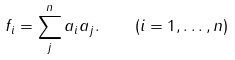Convert formula to latex. <formula><loc_0><loc_0><loc_500><loc_500>f _ { i } = \sum _ { j } ^ { n } { a _ { i } a _ { j } } . \quad ( i = 1 , \dots , n )</formula> 